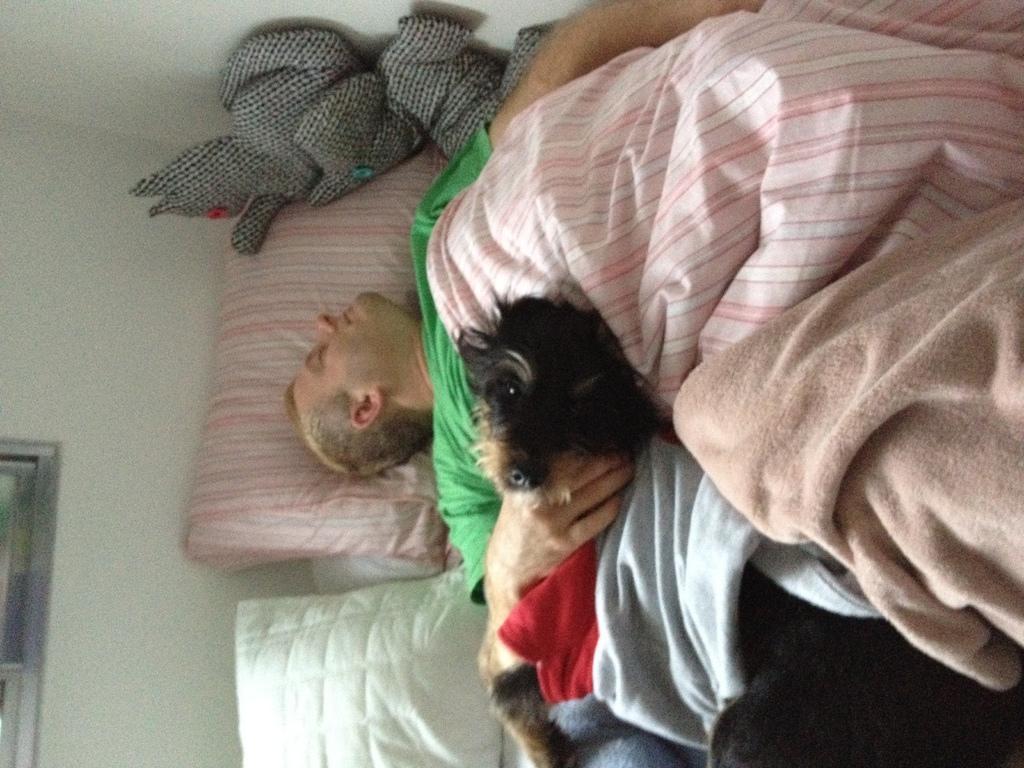Can you describe this image briefly? In this image I can see the person wearing green t shirt and a dog are sleeping on the bed. I can see few clothes, few pillows and the white colored wall. 